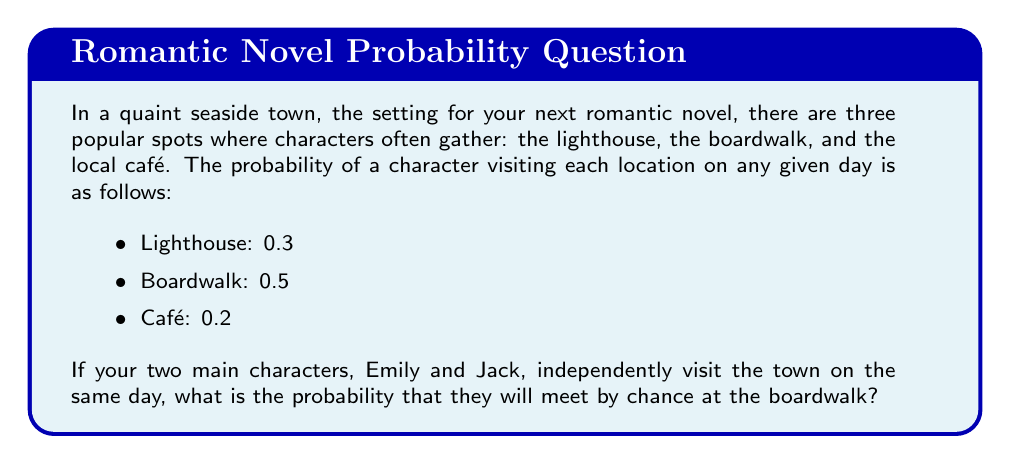Help me with this question. To solve this problem, we need to calculate the probability of both Emily and Jack choosing to visit the boardwalk on the same day. Since their decisions are independent, we can use the multiplication rule of probability.

Let's define the events:
- E: Emily visits the boardwalk
- J: Jack visits the boardwalk

We know that:
$P(E) = 0.5$ (probability of Emily visiting the boardwalk)
$P(J) = 0.5$ (probability of Jack visiting the boardwalk)

The probability of both events occurring is:

$$P(E \text{ and } J) = P(E) \times P(J)$$

Substituting the values:

$$P(E \text{ and } J) = 0.5 \times 0.5 = 0.25$$

Therefore, the probability of Emily and Jack meeting by chance at the boardwalk is 0.25 or 25%.

This result suggests that there's a one in four chance of your characters having a serendipitous encounter at the boardwalk, which could be the perfect setup for a romantic scene in your novel.
Answer: The probability of Emily and Jack meeting by chance at the boardwalk is $0.25$ or $25\%$. 